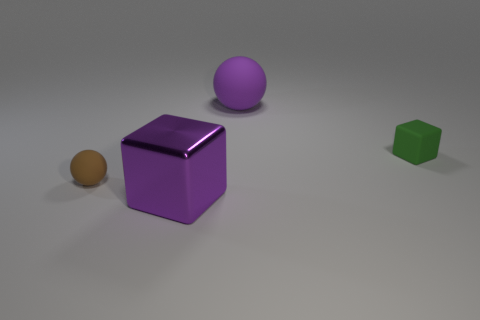Can you describe the lighting in the image? The lighting in the image is diffuse and soft, casting gentle shadows and suggesting an ambient light source above and slightly to the right of the composition. How does the lighting enhance the three-dimensionality of the objects? The soft shadows created by the lighting define the contours of the objects, enhancing their three-dimensionality and giving a sense of depth and placement within the space. 